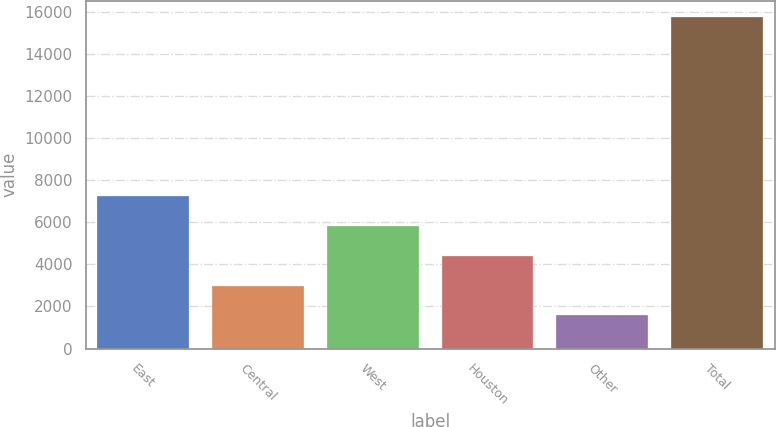Convert chart. <chart><loc_0><loc_0><loc_500><loc_500><bar_chart><fcel>East<fcel>Central<fcel>West<fcel>Houston<fcel>Other<fcel>Total<nl><fcel>7235.4<fcel>2985.6<fcel>5818.8<fcel>4402.2<fcel>1569<fcel>15735<nl></chart> 